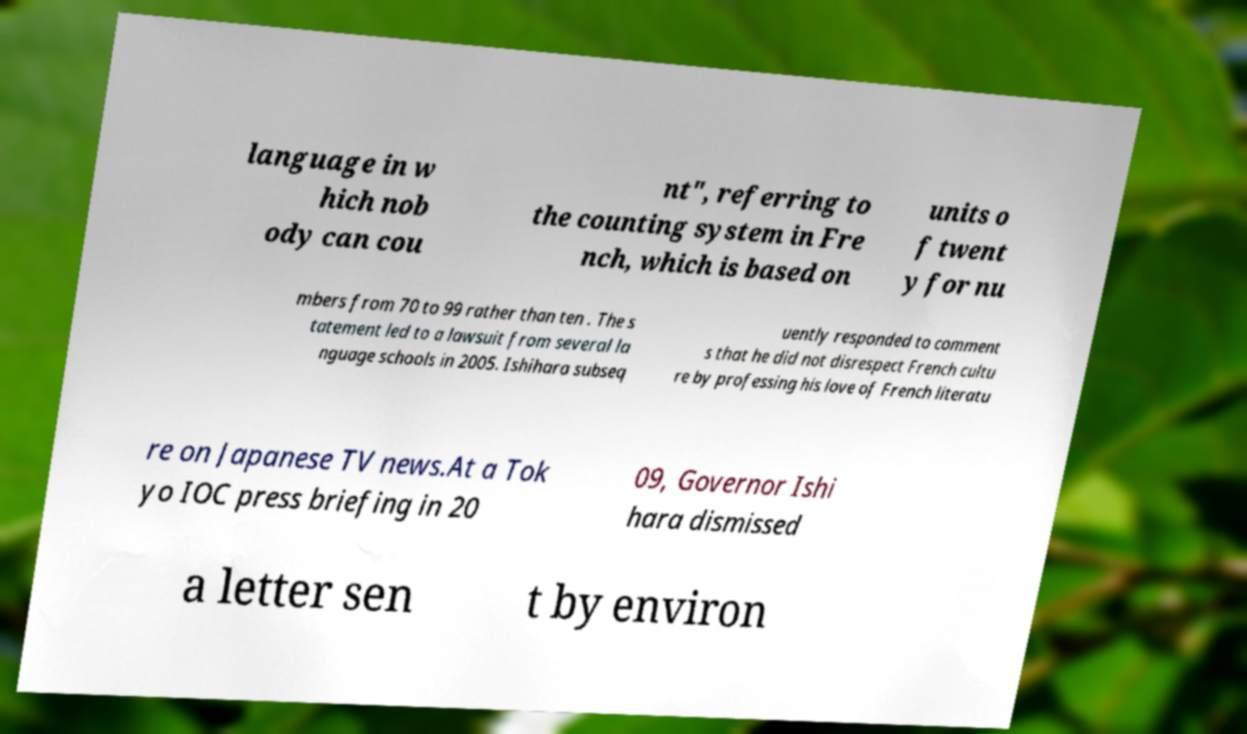Can you accurately transcribe the text from the provided image for me? language in w hich nob ody can cou nt", referring to the counting system in Fre nch, which is based on units o f twent y for nu mbers from 70 to 99 rather than ten . The s tatement led to a lawsuit from several la nguage schools in 2005. Ishihara subseq uently responded to comment s that he did not disrespect French cultu re by professing his love of French literatu re on Japanese TV news.At a Tok yo IOC press briefing in 20 09, Governor Ishi hara dismissed a letter sen t by environ 